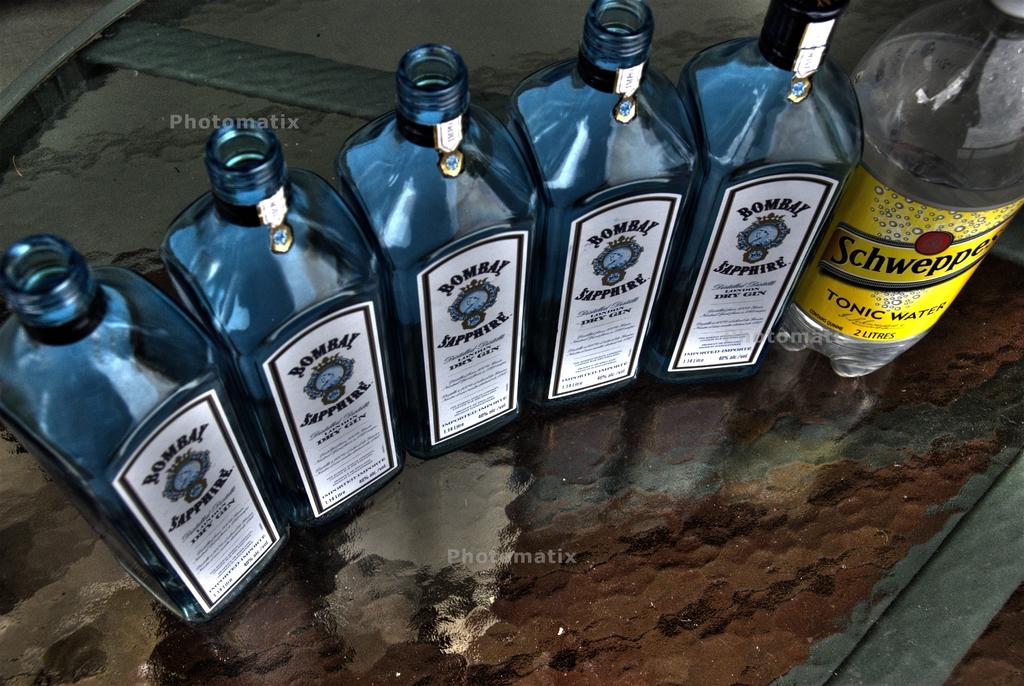What is the schweppes drink product shown?
Give a very brief answer. Tonic water. What is the brand of the 5 similar bottles?
Your response must be concise. Bombay sapphire. 